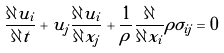Convert formula to latex. <formula><loc_0><loc_0><loc_500><loc_500>\frac { \partial u _ { i } } { \partial t } + u _ { j } \frac { \partial u _ { i } } { \partial x _ { j } } + \frac { 1 } { \rho } \frac { \partial } { \partial x _ { i } } \rho \sigma _ { i j } = 0</formula> 